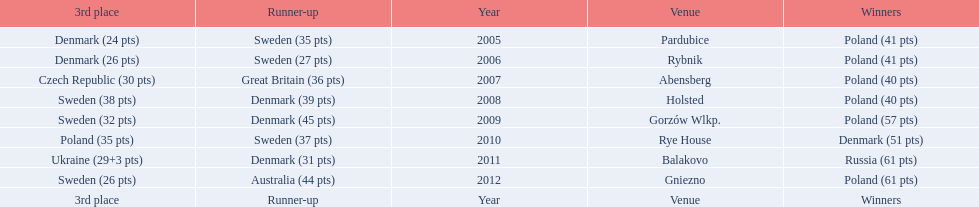From 2005-2012, in the team speedway junior world championship, how many more first place wins than all other teams put together? Poland. 